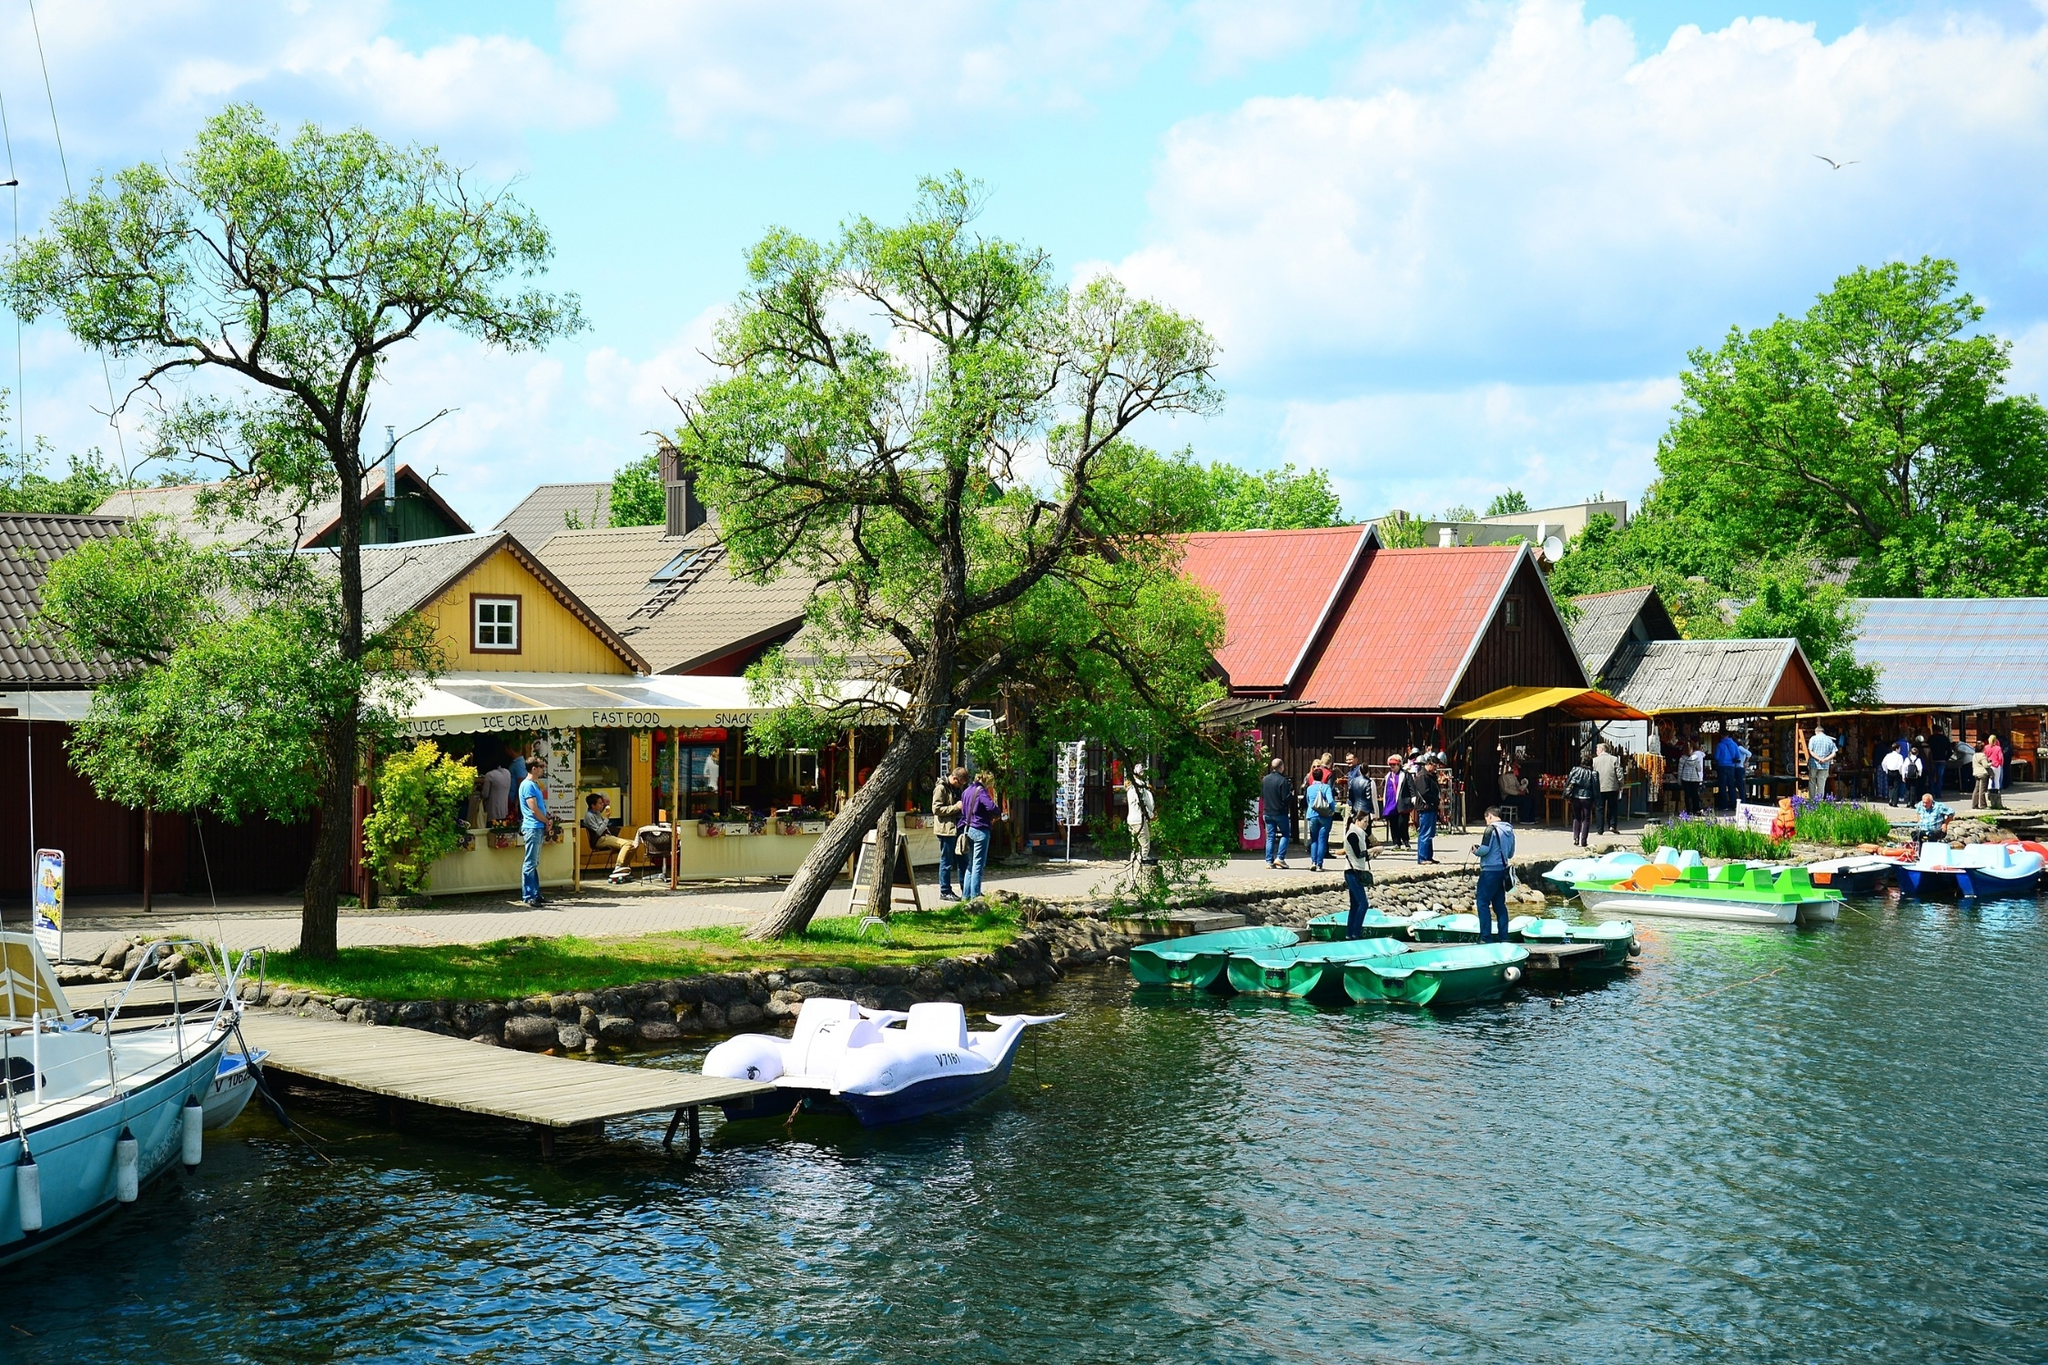Describe the activities that people might be doing in this village scene. In this vibrant village scene, people are engaged in various activities. Some are seen walking leisurely, enjoying the scenic beauty of the lakeside ambiance. A group of people is browsing items near the kiosks, likely purchasing snacks, ice cream, or fast food. Others are gathered in small groups, possibly chatting and enjoying each other's company. Near the dock, individuals are preparing to take the green and white paddle boats out onto the tranquil lake for a leisurely ride. This mix of activities creates a lively and inviting atmosphere in the village. 